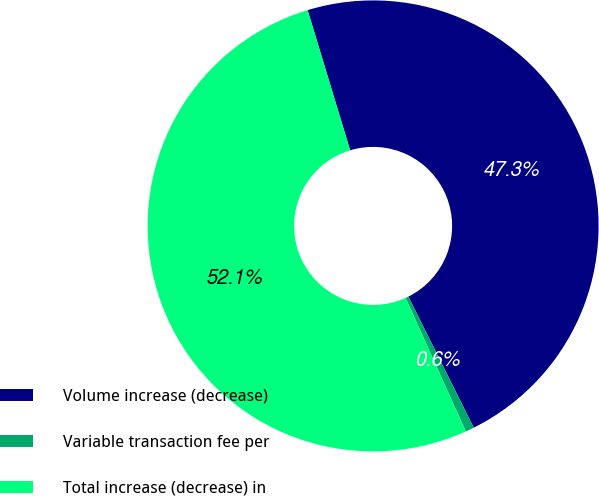Convert chart to OTSL. <chart><loc_0><loc_0><loc_500><loc_500><pie_chart><fcel>Volume increase (decrease)<fcel>Variable transaction fee per<fcel>Total increase (decrease) in<nl><fcel>47.32%<fcel>0.62%<fcel>52.05%<nl></chart> 